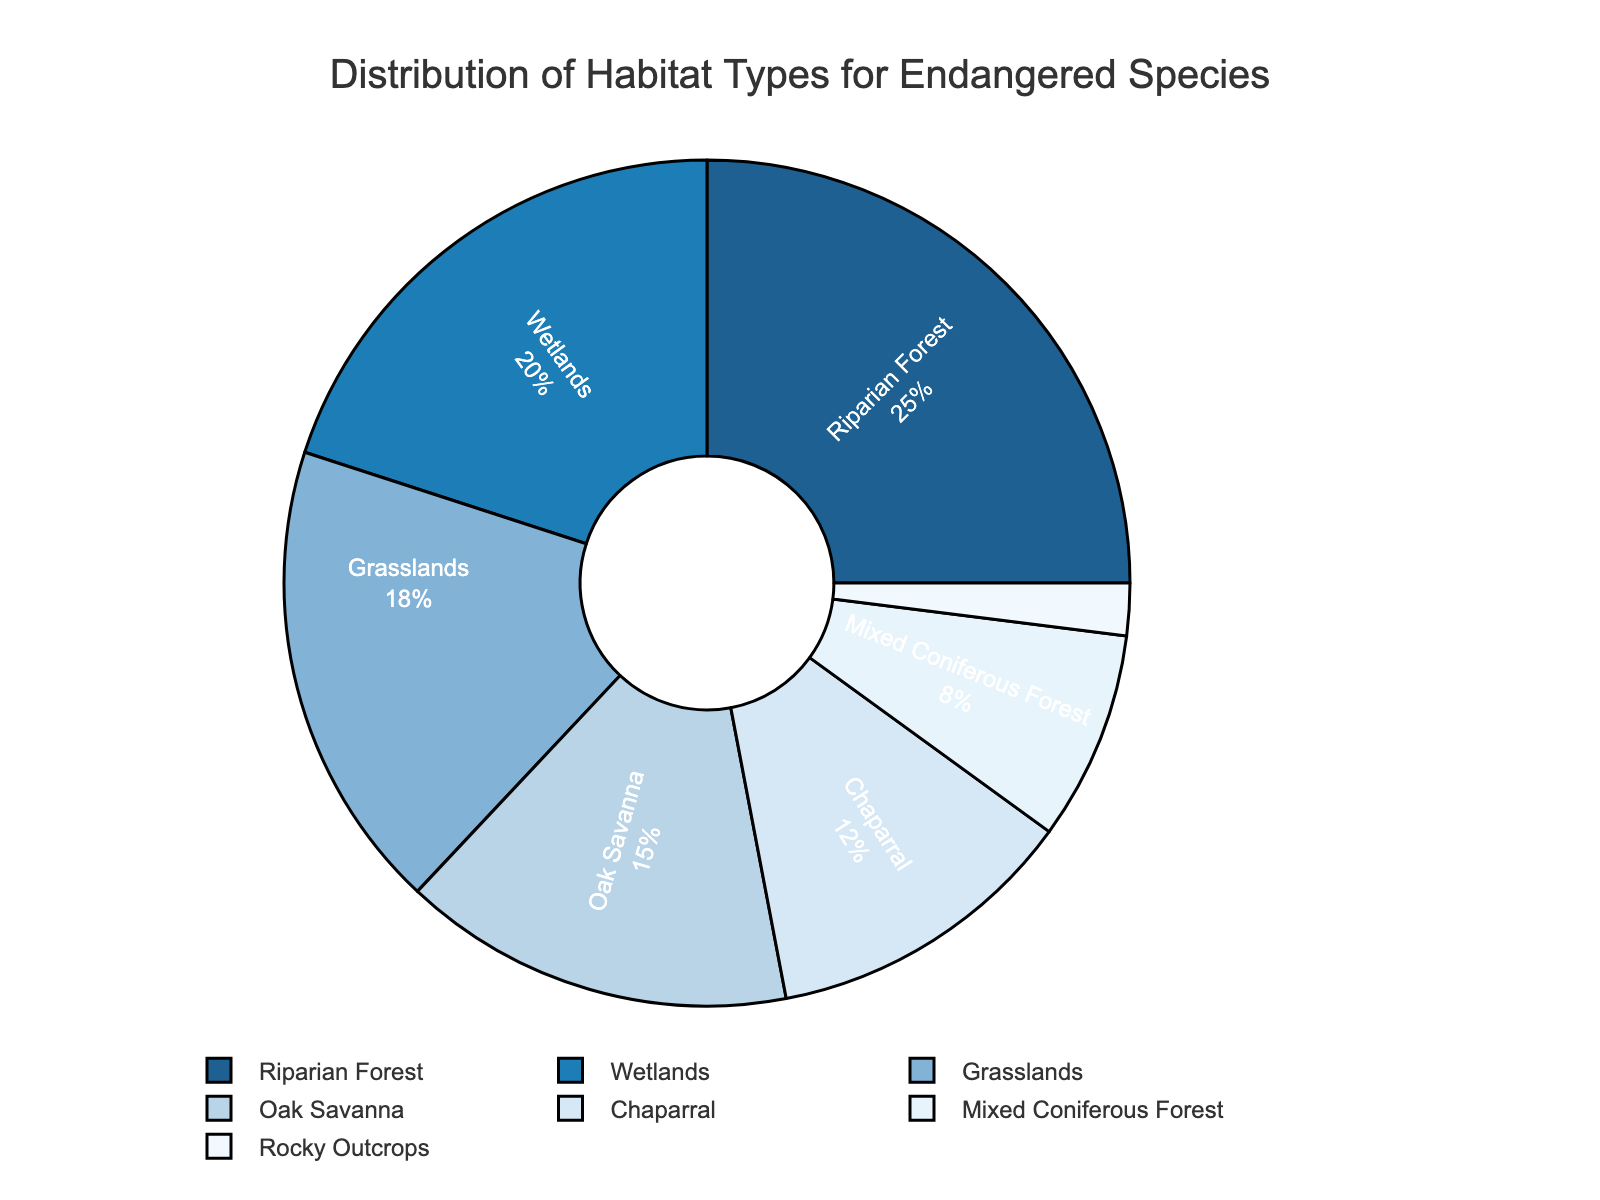What habitat type constitutes the largest proportion? The largest proportion can be identified by looking at the segment with the highest percentage. The "Riparian Forest" takes up the most space in the pie chart with 25%.
Answer: Riparian Forest Which habitat types combined make up more than half of the pie chart? Sum up the percentages from largest to smallest until you exceed 50%. "Riparian Forest" (25%), "Wetlands" (20%), and "Grasslands" (18%) together add up to 63%.
Answer: Riparian Forest, Wetlands, Grasslands What is the difference in percentage between the habitat types with the highest and lowest proportions? Subtract the smallest percentage from the largest. The "Riparian Forest" is 25% and the "Rocky Outcrops" is 2%, so 25% - 2% = 23%.
Answer: 23% Compare the total percentage of "Grasslands" and "Oak Savanna" to "Riparian Forest". Which is higher? Add the percentages of "Grasslands" and "Oak Savanna" and compare to "Riparian Forest". (18% + 15%) = 33% which is greater than "Riparian Forest" (25%).
Answer: Grasslands and Oak Savanna What percentage of the chart do "Mixed Coniferous Forest" and "Rocky Outcrops" collectively represent? Add the percentages of the "Mixed Coniferous Forest" and "Rocky Outcrops". 8% + 2% = 10%.
Answer: 10% How does the proportion of "Chaparral" compare with the sum of "Mixed Coniferous Forest" and "Rocky Outcrops"? Compare the percentages directly. "Chaparral" is 12%, while "Mixed Coniferous Forest" and "Rocky Outcrops" together are 10%. 12% > 10%.
Answer: Chaparral is larger What is the combined percentage of "Riparian Forest," "Wetlands," and "Grasslands"? Add the percentages of "Riparian Forest," "Wetlands," and "Grasslands." 25% + 20% + 18% = 63%.
Answer: 63% What proportion of the habitats is represented by "Oak Savanna" relative to the "Mixed Coniferous Forest"? Divide the percentage of "Oak Savanna" by "Mixed Coniferous Forest" and multiply by 100. (15% / 8%) * 100 = 187.5%.
Answer: 187.5% Which habitat types have similar percentages? Observe the segments with closely matching proportions. "Grasslands" (18%) and "Oak Savanna" (15%) have similar percentages.
Answer: Grasslands and Oak Savanna 